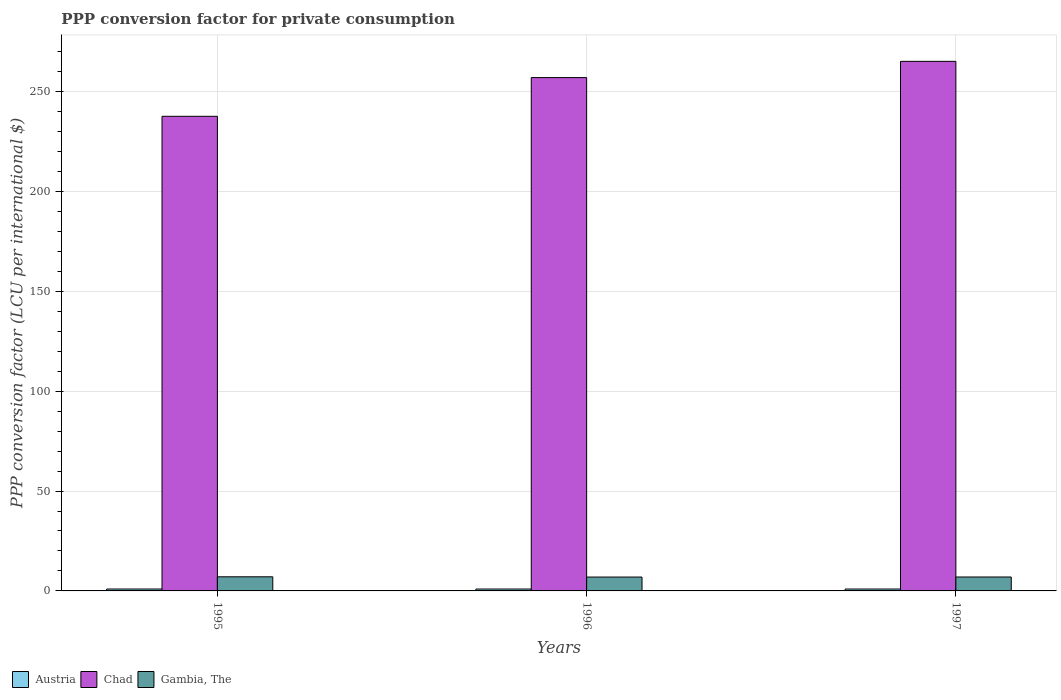How many different coloured bars are there?
Your answer should be very brief. 3. How many groups of bars are there?
Your answer should be compact. 3. How many bars are there on the 2nd tick from the left?
Offer a very short reply. 3. What is the PPP conversion factor for private consumption in Gambia, The in 1996?
Provide a succinct answer. 6.94. Across all years, what is the maximum PPP conversion factor for private consumption in Chad?
Ensure brevity in your answer.  265.09. Across all years, what is the minimum PPP conversion factor for private consumption in Chad?
Make the answer very short. 237.58. In which year was the PPP conversion factor for private consumption in Chad minimum?
Your answer should be very brief. 1995. What is the total PPP conversion factor for private consumption in Chad in the graph?
Keep it short and to the point. 759.65. What is the difference between the PPP conversion factor for private consumption in Chad in 1995 and that in 1997?
Make the answer very short. -27.51. What is the difference between the PPP conversion factor for private consumption in Austria in 1996 and the PPP conversion factor for private consumption in Chad in 1995?
Make the answer very short. -236.63. What is the average PPP conversion factor for private consumption in Gambia, The per year?
Your answer should be compact. 6.99. In the year 1995, what is the difference between the PPP conversion factor for private consumption in Austria and PPP conversion factor for private consumption in Gambia, The?
Your response must be concise. -6.11. What is the ratio of the PPP conversion factor for private consumption in Austria in 1996 to that in 1997?
Make the answer very short. 1. What is the difference between the highest and the second highest PPP conversion factor for private consumption in Austria?
Your response must be concise. 0. What is the difference between the highest and the lowest PPP conversion factor for private consumption in Gambia, The?
Make the answer very short. 0.13. What does the 3rd bar from the right in 1996 represents?
Your response must be concise. Austria. Are all the bars in the graph horizontal?
Ensure brevity in your answer.  No. How many years are there in the graph?
Ensure brevity in your answer.  3. Are the values on the major ticks of Y-axis written in scientific E-notation?
Make the answer very short. No. Does the graph contain grids?
Your response must be concise. Yes. Where does the legend appear in the graph?
Provide a short and direct response. Bottom left. How are the legend labels stacked?
Keep it short and to the point. Horizontal. What is the title of the graph?
Ensure brevity in your answer.  PPP conversion factor for private consumption. Does "Cambodia" appear as one of the legend labels in the graph?
Offer a terse response. No. What is the label or title of the Y-axis?
Your answer should be compact. PPP conversion factor (LCU per international $). What is the PPP conversion factor (LCU per international $) of Austria in 1995?
Ensure brevity in your answer.  0.95. What is the PPP conversion factor (LCU per international $) of Chad in 1995?
Offer a terse response. 237.58. What is the PPP conversion factor (LCU per international $) of Gambia, The in 1995?
Provide a short and direct response. 7.07. What is the PPP conversion factor (LCU per international $) in Austria in 1996?
Ensure brevity in your answer.  0.95. What is the PPP conversion factor (LCU per international $) in Chad in 1996?
Provide a short and direct response. 256.97. What is the PPP conversion factor (LCU per international $) of Gambia, The in 1996?
Make the answer very short. 6.94. What is the PPP conversion factor (LCU per international $) in Austria in 1997?
Make the answer very short. 0.95. What is the PPP conversion factor (LCU per international $) of Chad in 1997?
Provide a succinct answer. 265.09. What is the PPP conversion factor (LCU per international $) in Gambia, The in 1997?
Your answer should be very brief. 6.97. Across all years, what is the maximum PPP conversion factor (LCU per international $) in Austria?
Make the answer very short. 0.95. Across all years, what is the maximum PPP conversion factor (LCU per international $) in Chad?
Your response must be concise. 265.09. Across all years, what is the maximum PPP conversion factor (LCU per international $) of Gambia, The?
Your response must be concise. 7.07. Across all years, what is the minimum PPP conversion factor (LCU per international $) in Austria?
Provide a succinct answer. 0.95. Across all years, what is the minimum PPP conversion factor (LCU per international $) in Chad?
Keep it short and to the point. 237.58. Across all years, what is the minimum PPP conversion factor (LCU per international $) in Gambia, The?
Offer a very short reply. 6.94. What is the total PPP conversion factor (LCU per international $) of Austria in the graph?
Ensure brevity in your answer.  2.85. What is the total PPP conversion factor (LCU per international $) in Chad in the graph?
Provide a succinct answer. 759.65. What is the total PPP conversion factor (LCU per international $) of Gambia, The in the graph?
Keep it short and to the point. 20.98. What is the difference between the PPP conversion factor (LCU per international $) of Austria in 1995 and that in 1996?
Provide a short and direct response. 0. What is the difference between the PPP conversion factor (LCU per international $) of Chad in 1995 and that in 1996?
Your answer should be very brief. -19.39. What is the difference between the PPP conversion factor (LCU per international $) in Gambia, The in 1995 and that in 1996?
Give a very brief answer. 0.13. What is the difference between the PPP conversion factor (LCU per international $) in Austria in 1995 and that in 1997?
Provide a succinct answer. 0.01. What is the difference between the PPP conversion factor (LCU per international $) of Chad in 1995 and that in 1997?
Provide a short and direct response. -27.51. What is the difference between the PPP conversion factor (LCU per international $) in Gambia, The in 1995 and that in 1997?
Your response must be concise. 0.1. What is the difference between the PPP conversion factor (LCU per international $) in Austria in 1996 and that in 1997?
Give a very brief answer. 0. What is the difference between the PPP conversion factor (LCU per international $) in Chad in 1996 and that in 1997?
Ensure brevity in your answer.  -8.12. What is the difference between the PPP conversion factor (LCU per international $) in Gambia, The in 1996 and that in 1997?
Offer a terse response. -0.03. What is the difference between the PPP conversion factor (LCU per international $) of Austria in 1995 and the PPP conversion factor (LCU per international $) of Chad in 1996?
Your answer should be very brief. -256.02. What is the difference between the PPP conversion factor (LCU per international $) in Austria in 1995 and the PPP conversion factor (LCU per international $) in Gambia, The in 1996?
Make the answer very short. -5.99. What is the difference between the PPP conversion factor (LCU per international $) of Chad in 1995 and the PPP conversion factor (LCU per international $) of Gambia, The in 1996?
Your answer should be very brief. 230.64. What is the difference between the PPP conversion factor (LCU per international $) in Austria in 1995 and the PPP conversion factor (LCU per international $) in Chad in 1997?
Keep it short and to the point. -264.14. What is the difference between the PPP conversion factor (LCU per international $) of Austria in 1995 and the PPP conversion factor (LCU per international $) of Gambia, The in 1997?
Your answer should be compact. -6.02. What is the difference between the PPP conversion factor (LCU per international $) of Chad in 1995 and the PPP conversion factor (LCU per international $) of Gambia, The in 1997?
Offer a very short reply. 230.61. What is the difference between the PPP conversion factor (LCU per international $) of Austria in 1996 and the PPP conversion factor (LCU per international $) of Chad in 1997?
Keep it short and to the point. -264.14. What is the difference between the PPP conversion factor (LCU per international $) in Austria in 1996 and the PPP conversion factor (LCU per international $) in Gambia, The in 1997?
Provide a short and direct response. -6.02. What is the difference between the PPP conversion factor (LCU per international $) in Chad in 1996 and the PPP conversion factor (LCU per international $) in Gambia, The in 1997?
Provide a short and direct response. 250. What is the average PPP conversion factor (LCU per international $) of Austria per year?
Provide a short and direct response. 0.95. What is the average PPP conversion factor (LCU per international $) in Chad per year?
Ensure brevity in your answer.  253.22. What is the average PPP conversion factor (LCU per international $) of Gambia, The per year?
Ensure brevity in your answer.  6.99. In the year 1995, what is the difference between the PPP conversion factor (LCU per international $) in Austria and PPP conversion factor (LCU per international $) in Chad?
Provide a short and direct response. -236.63. In the year 1995, what is the difference between the PPP conversion factor (LCU per international $) of Austria and PPP conversion factor (LCU per international $) of Gambia, The?
Ensure brevity in your answer.  -6.11. In the year 1995, what is the difference between the PPP conversion factor (LCU per international $) of Chad and PPP conversion factor (LCU per international $) of Gambia, The?
Provide a short and direct response. 230.52. In the year 1996, what is the difference between the PPP conversion factor (LCU per international $) in Austria and PPP conversion factor (LCU per international $) in Chad?
Give a very brief answer. -256.02. In the year 1996, what is the difference between the PPP conversion factor (LCU per international $) of Austria and PPP conversion factor (LCU per international $) of Gambia, The?
Ensure brevity in your answer.  -5.99. In the year 1996, what is the difference between the PPP conversion factor (LCU per international $) in Chad and PPP conversion factor (LCU per international $) in Gambia, The?
Give a very brief answer. 250.03. In the year 1997, what is the difference between the PPP conversion factor (LCU per international $) in Austria and PPP conversion factor (LCU per international $) in Chad?
Provide a succinct answer. -264.15. In the year 1997, what is the difference between the PPP conversion factor (LCU per international $) of Austria and PPP conversion factor (LCU per international $) of Gambia, The?
Your answer should be compact. -6.02. In the year 1997, what is the difference between the PPP conversion factor (LCU per international $) in Chad and PPP conversion factor (LCU per international $) in Gambia, The?
Offer a very short reply. 258.12. What is the ratio of the PPP conversion factor (LCU per international $) in Austria in 1995 to that in 1996?
Give a very brief answer. 1. What is the ratio of the PPP conversion factor (LCU per international $) of Chad in 1995 to that in 1996?
Your response must be concise. 0.92. What is the ratio of the PPP conversion factor (LCU per international $) of Gambia, The in 1995 to that in 1996?
Your answer should be compact. 1.02. What is the ratio of the PPP conversion factor (LCU per international $) of Austria in 1995 to that in 1997?
Provide a short and direct response. 1.01. What is the ratio of the PPP conversion factor (LCU per international $) of Chad in 1995 to that in 1997?
Your answer should be very brief. 0.9. What is the ratio of the PPP conversion factor (LCU per international $) in Gambia, The in 1995 to that in 1997?
Provide a succinct answer. 1.01. What is the ratio of the PPP conversion factor (LCU per international $) in Austria in 1996 to that in 1997?
Make the answer very short. 1. What is the ratio of the PPP conversion factor (LCU per international $) in Chad in 1996 to that in 1997?
Your answer should be very brief. 0.97. What is the difference between the highest and the second highest PPP conversion factor (LCU per international $) of Austria?
Ensure brevity in your answer.  0. What is the difference between the highest and the second highest PPP conversion factor (LCU per international $) of Chad?
Give a very brief answer. 8.12. What is the difference between the highest and the second highest PPP conversion factor (LCU per international $) in Gambia, The?
Your answer should be compact. 0.1. What is the difference between the highest and the lowest PPP conversion factor (LCU per international $) in Austria?
Provide a short and direct response. 0.01. What is the difference between the highest and the lowest PPP conversion factor (LCU per international $) of Chad?
Make the answer very short. 27.51. What is the difference between the highest and the lowest PPP conversion factor (LCU per international $) of Gambia, The?
Ensure brevity in your answer.  0.13. 